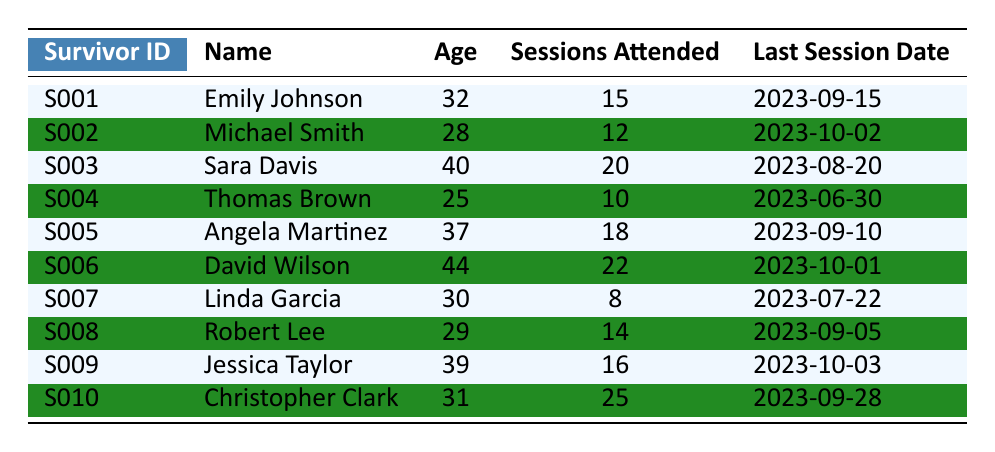What is the name of the survivor who attended the most counseling sessions? By looking at the "Sessions Attended" column, I can see that the highest number is 25, which belongs to Christopher Clark, whose name is in the same row.
Answer: Christopher Clark How many sessions did Angela Martinez attend? The table shows that Angela Martinez attended 18 sessions, as stated in the "Sessions Attended" column.
Answer: 18 Is it true that Michael Smith attended more than 10 sessions? I check the "Sessions Attended" column for Michael Smith, which indicates he attended 12 sessions, so the statement is true.
Answer: Yes What is the average number of sessions attended by all survivors? To find the average, I sum all the sessions attended (15 + 12 + 20 + 10 + 18 + 22 + 8 + 14 + 16 + 25 =  150) and divide by the number of survivors (10). The average is 150/10 = 15.
Answer: 15 Who had the last session on the latest date? The latest date in the "Last Session Date" column is 2023-10-03, which corresponds to Jessica Taylor, indicating she had the last session most recently.
Answer: Jessica Taylor How many survivors attended fewer than 10 sessions? By reviewing the "Sessions Attended" column, Linda Garcia is the only survivor who attended fewer than 10 sessions (8 sessions), meaning there is only one survivor.
Answer: 1 What is the difference in the number of sessions attended between the survivor with the most sessions and the one with the least? The most sessions attended is 25 by Christopher Clark, and the least is 8 by Linda Garcia. The difference is 25 - 8 = 17.
Answer: 17 How many survivors are aged over 35 who attended sessions? I count the survivors aged over 35 from the table: Emily Johnson (32, not counted), Michael Smith (28, not counted), Sara Davis (40, counted), Thomas Brown (25, not counted), Angela Martinez (37, counted), David Wilson (44, counted), Linda Garcia (30, not counted), Robert Lee (29, not counted), Jessica Taylor (39, counted), Christopher Clark (31, not counted). Thus, there are 3 survivors who are over 35.
Answer: 3 What is the total number of sessions attended by survivors aged 30 and younger? I look through the table, and the survivors aged 30 and younger are Thomas Brown (10 sessions), Michael Smith (12 sessions), and Linda Garcia (8 sessions). Thus, the total is 10 + 12 + 8 = 30.
Answer: 30 